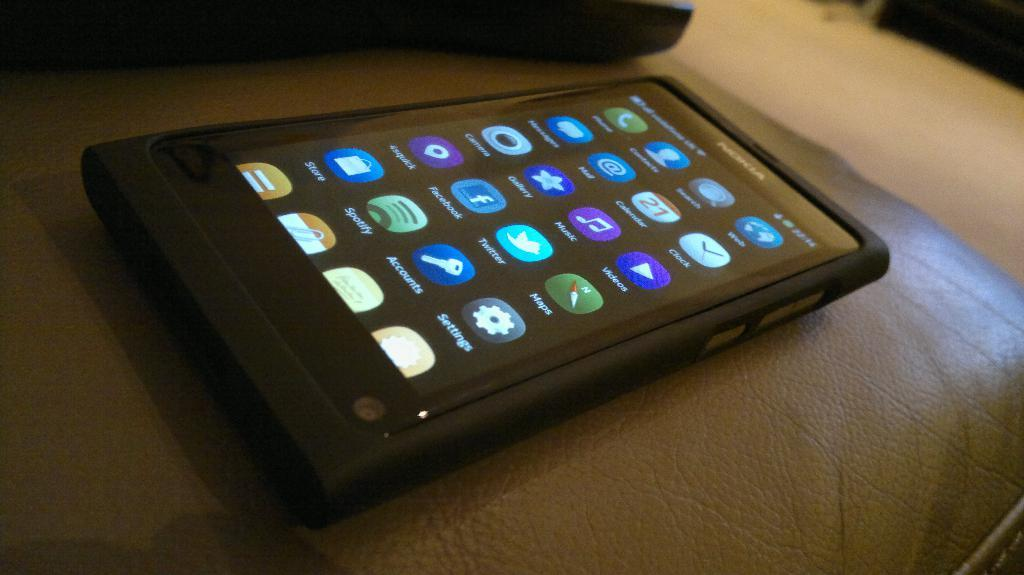What electronic device is visible in the image? There is a mobile phone in the image. Where is the mobile phone located? The mobile phone is on a sofa. What part of the mobile phone is visible in the image? The image shows the screen of the device. What type of bell can be heard ringing in the image? There is no bell present in the image, and therefore no sound can be heard. 